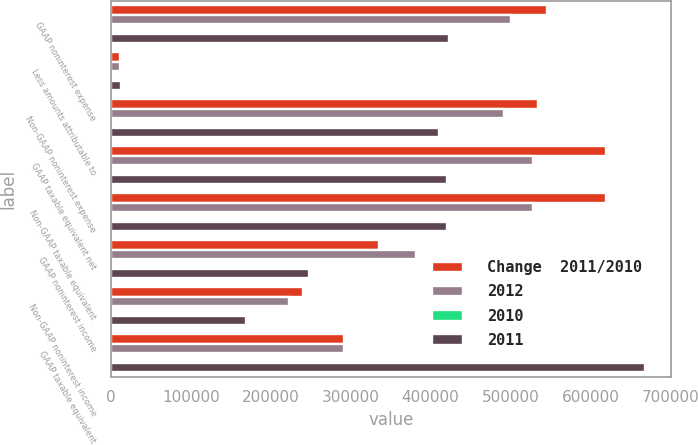Convert chart. <chart><loc_0><loc_0><loc_500><loc_500><stacked_bar_chart><ecel><fcel>GAAP noninterest expense<fcel>Less amounts attributable to<fcel>Non-GAAP noninterest expense<fcel>GAAP taxable equivalent net<fcel>Non-GAAP taxable equivalent<fcel>GAAP noninterest income<fcel>Non-GAAP noninterest income<fcel>GAAP taxable equivalent<nl><fcel>Change  2011/2010<fcel>545998<fcel>11336<fcel>534662<fcel>619783<fcel>619677<fcel>335546<fcel>240408<fcel>291538<nl><fcel>2012<fcel>500628<fcel>11567<fcel>492184<fcel>528228<fcel>528106<fcel>382332<fcel>222682<fcel>291538<nl><fcel>2010<fcel>9.1<fcel>2<fcel>8.6<fcel>17.3<fcel>17.3<fcel>12.2<fcel>8<fcel>4.9<nl><fcel>2011<fcel>422818<fcel>12348<fcel>410470<fcel>420186<fcel>420158<fcel>247530<fcel>168645<fcel>667716<nl></chart> 